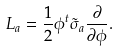Convert formula to latex. <formula><loc_0><loc_0><loc_500><loc_500>L _ { a } = \frac { 1 } { 2 } \phi ^ { t } \tilde { \sigma } _ { a } \frac { \partial } { \partial \phi } .</formula> 